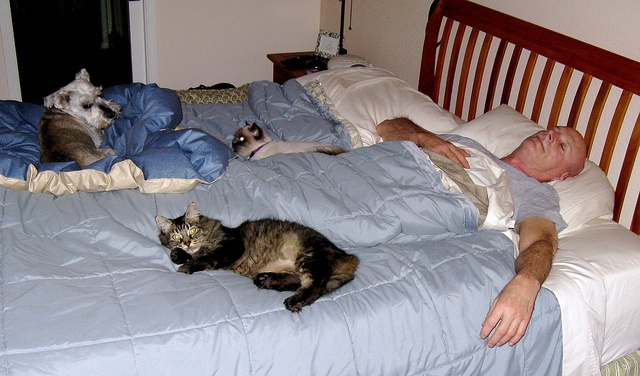Describe the objects in this image and their specific colors. I can see bed in darkgray, lightgray, and maroon tones, people in darkgray, brown, and lightpink tones, cat in darkgray, black, gray, and maroon tones, dog in darkgray, black, gray, and maroon tones, and cat in darkgray, gray, and black tones in this image. 